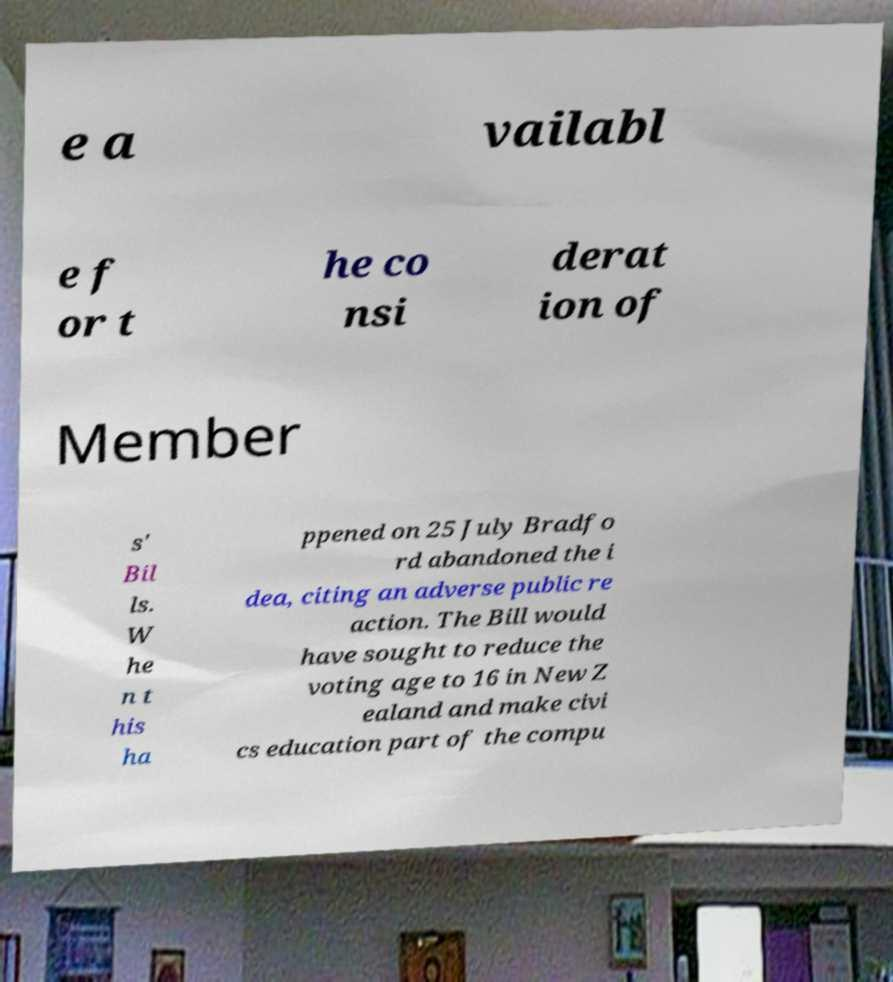What messages or text are displayed in this image? I need them in a readable, typed format. e a vailabl e f or t he co nsi derat ion of Member s' Bil ls. W he n t his ha ppened on 25 July Bradfo rd abandoned the i dea, citing an adverse public re action. The Bill would have sought to reduce the voting age to 16 in New Z ealand and make civi cs education part of the compu 